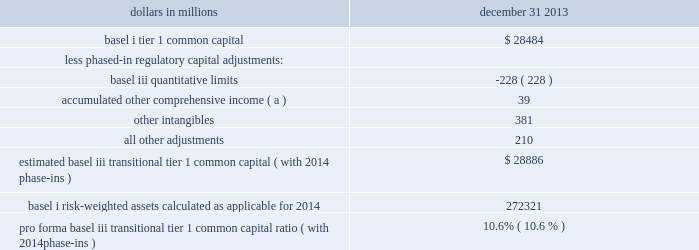Table 20 : pro forma transitional basel iii tier 1 common capital ratio dollars in millions december 31 .
Estimated basel iii transitional tier 1 common capital ( with 2014 phase-ins ) $ 28886 basel i risk-weighted assets calculated as applicable for 2014 272321 pro forma basel iii transitional tier 1 common capital ratio ( with 2014 phase-ins ) 10.6% ( 10.6 % ) ( a ) represents net adjustments related to accumulated other comprehensive income for available for sale securities and pension and other postretirement benefit plans .
Pnc utilizes these fully implemented and transitional basel iii capital ratios to assess its capital position , including comparison to similar estimates made by other financial institutions .
These basel iii capital estimates are likely to be impacted by any additional regulatory guidance , continued analysis by pnc as to the application of the rules to pnc , and in the case of ratios calculated using the advanced approaches , the ongoing evolution , validation and regulatory approval of pnc 2019s models integral to the calculation of advanced approaches risk-weighted assets .
The access to and cost of funding for new business initiatives , the ability to undertake new business initiatives including acquisitions , the ability to engage in expanded business activities , the ability to pay dividends or repurchase shares or other capital instruments , the level of deposit insurance costs , and the level and nature of regulatory oversight depend , in large part , on a financial institution 2019s capital strength .
We provide additional information regarding enhanced capital requirements and some of their potential impacts on pnc in item 1 business 2013 supervision and regulation , item 1a risk factors and note 22 regulatory matters in the notes to consolidated financial statements in item 8 of this report .
Off-balance sheet arrangements and variable interest entities we engage in a variety of activities that involve unconsolidated entities or that are otherwise not reflected in our consolidated balance sheet that are generally referred to as 201coff-balance sheet arrangements . 201d additional information on these types of activities is included in the following sections of this report : 2022 commitments , including contractual obligations and other commitments , included within the risk management section of this item 7 , 2022 note 3 loan sale and servicing activities and variable interest entities in the notes to consolidated financial statements included in item 8 of this report , 2022 note 14 capital securities of subsidiary trusts and perpetual trust securities in the notes to consolidated financial statements included in item 8 of this report , and 2022 note 24 commitments and guarantees in the notes to consolidated financial statements included in item 8 of this report .
Pnc consolidates variable interest entities ( vies ) when we are deemed to be the primary beneficiary .
The primary beneficiary of a vie is determined to be the party that meets both of the following criteria : ( i ) has the power to make decisions that most significantly affect the economic performance of the vie ; and ( ii ) has the obligation to absorb losses or the right to receive benefits that in either case could potentially be significant to the vie .
A summary of vies , including those that we have consolidated and those in which we hold variable interests but have not consolidated into our financial statements , as of december 31 , 2013 and december 31 , 2012 is included in note 3 in the notes to consolidated financial statements included in item 8 of this report .
Trust preferred securities and reit preferred securities we are subject to certain restrictions , including restrictions on dividend payments , in connection with $ 206 million in principal amount of an outstanding junior subordinated debenture associated with $ 200 million of trust preferred securities ( both amounts as of december 31 , 2013 ) that were issued by pnc capital trust c , a subsidiary statutory trust .
Generally , if there is ( i ) an event of default under the debenture , ( ii ) pnc elects to defer interest on the debenture , ( iii ) pnc exercises its right to defer payments on the related trust preferred security issued by the statutory trust , or ( iv ) there is a default under pnc 2019s guarantee of such payment obligations , as specified in the applicable governing documents , then pnc would be subject during the period of such default or deferral to restrictions on dividends and other provisions protecting the status of the debenture holders similar to or in some ways more restrictive than those potentially imposed under the exchange agreement with pnc preferred funding trust ii .
See note 14 capital securities of subsidiary trusts and perpetual trust securities in the notes to consolidated financial statements in item 8 of this report for additional information on contractual limitations on dividend payments resulting from securities issued by pnc preferred funding trust i and pnc preferred funding trust ii .
See the liquidity risk management portion of the risk management section of this item 7 for additional information regarding our first quarter 2013 redemption of the reit preferred securities issued by pnc preferred funding trust iii and additional discussion of redemptions of trust preferred securities .
48 the pnc financial services group , inc .
2013 form 10-k .
For 2013 , in millions , what was the total of other intangibles and all other adjustments? 
Computations: (381 + 210)
Answer: 591.0. 